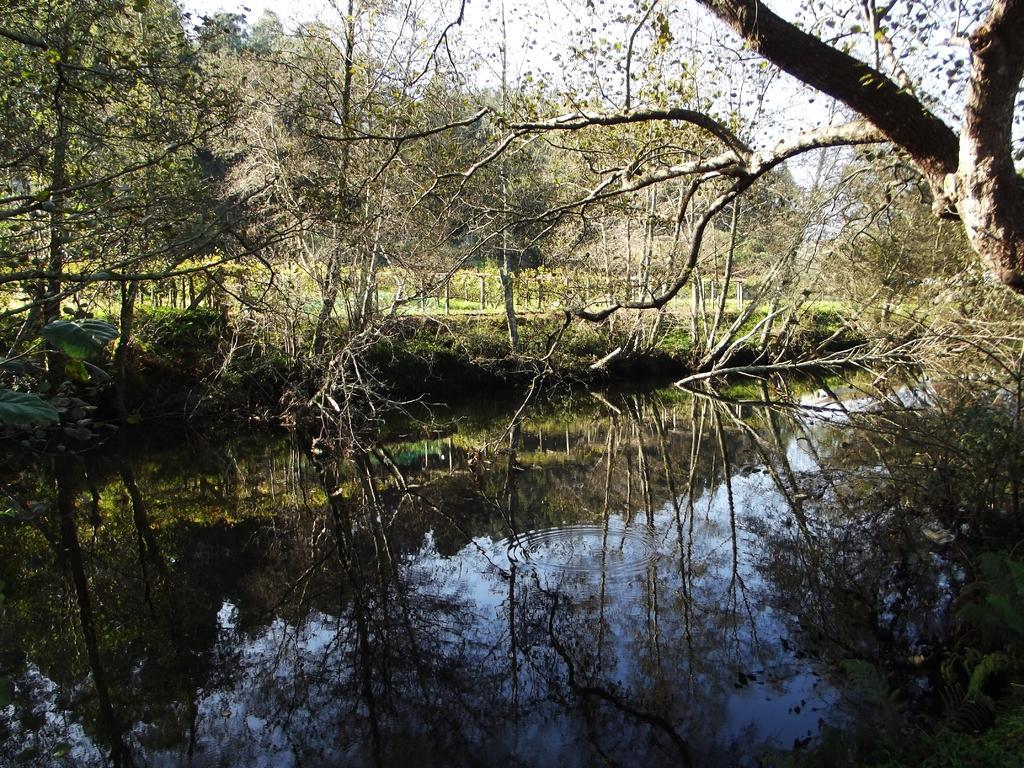How would you summarize this image in a sentence or two? We can see trees,grass and sky and we can see the reflection of trees in the water. 